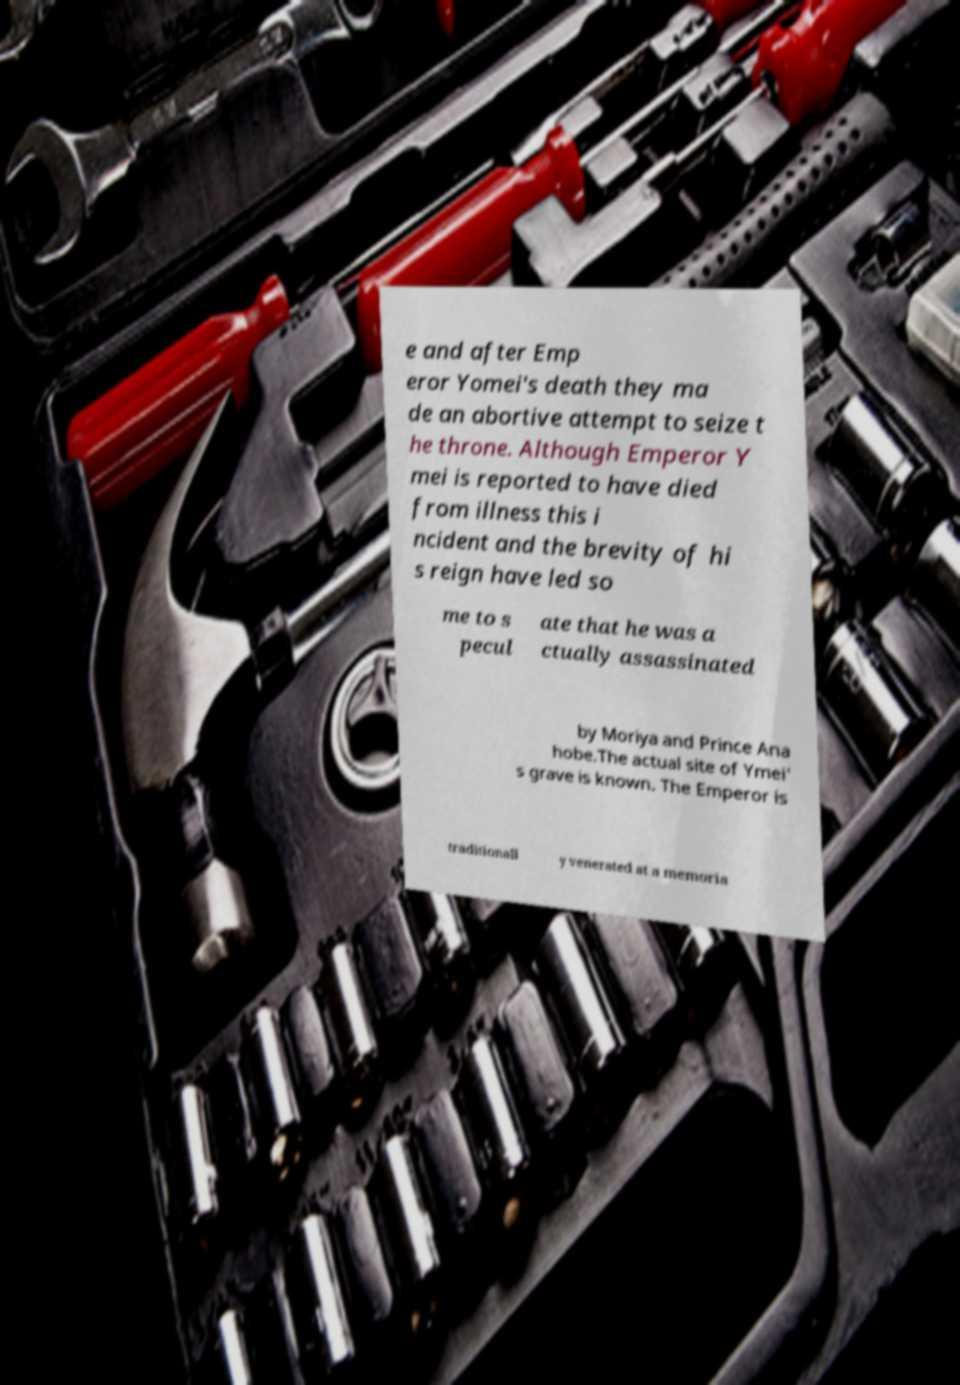What messages or text are displayed in this image? I need them in a readable, typed format. e and after Emp eror Yomei's death they ma de an abortive attempt to seize t he throne. Although Emperor Y mei is reported to have died from illness this i ncident and the brevity of hi s reign have led so me to s pecul ate that he was a ctually assassinated by Moriya and Prince Ana hobe.The actual site of Ymei' s grave is known. The Emperor is traditionall y venerated at a memoria 